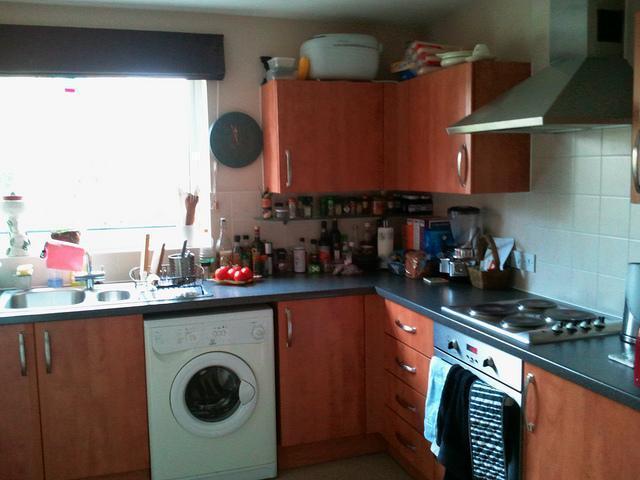What material is the sink made of?
Make your selection from the four choices given to correctly answer the question.
Options: Wood, plastic, stainless steel, porcelain. Stainless steel. 